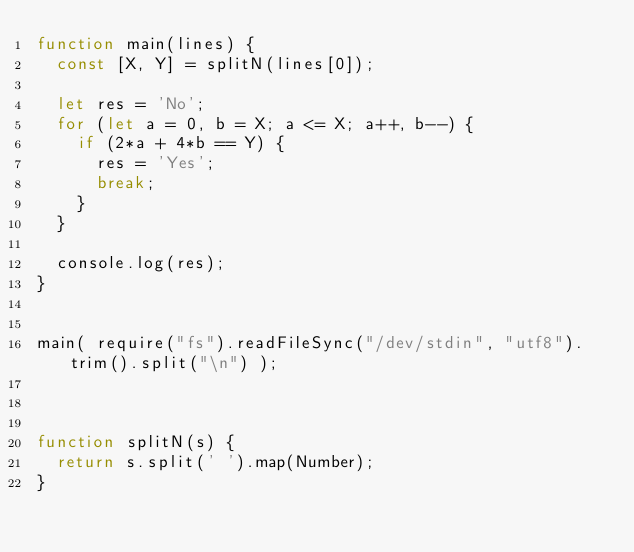<code> <loc_0><loc_0><loc_500><loc_500><_JavaScript_>function main(lines) {
  const [X, Y] = splitN(lines[0]);
  
  let res = 'No';
  for (let a = 0, b = X; a <= X; a++, b--) {
    if (2*a + 4*b == Y) {
      res = 'Yes';
      break;
    }
  }
  
  console.log(res);
}


main( require("fs").readFileSync("/dev/stdin", "utf8").trim().split("\n") );



function splitN(s) {
  return s.split(' ').map(Number);
}</code> 